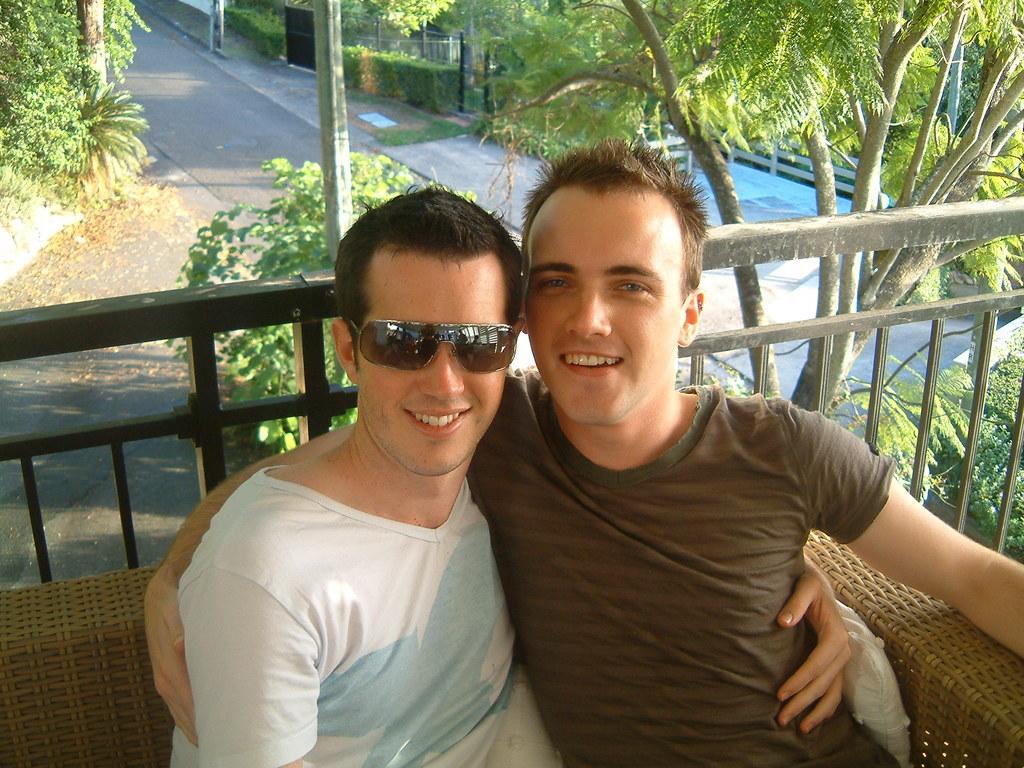Please provide a concise description of this image. In this image I can see two men are sitting and I can see smile on their faces. I can also see both of them are wearing t shirts and one of them is wearing shades. In the background I can see number of trees and bushes over there. 